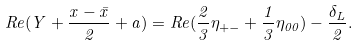Convert formula to latex. <formula><loc_0><loc_0><loc_500><loc_500>R e ( Y + \frac { x - \bar { x } } { 2 } + a ) = R e ( \frac { 2 } { 3 } \eta _ { + - } + \frac { 1 } { 3 } \eta _ { 0 0 } ) - \frac { \delta _ { L } } { 2 } .</formula> 